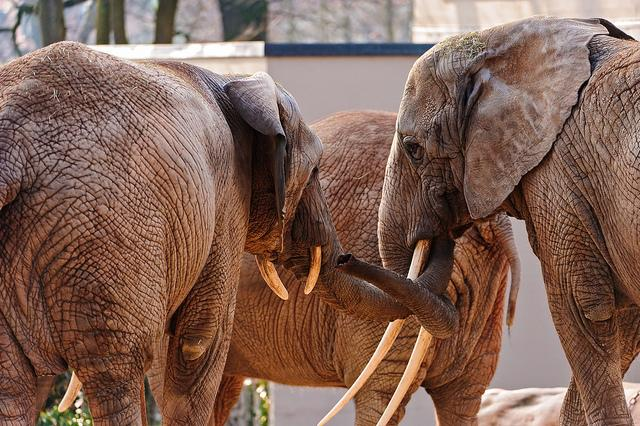How many big elephants are inside of this zoo enclosure together? Please explain your reasoning. three. You can count 3 elephants standing closely together 